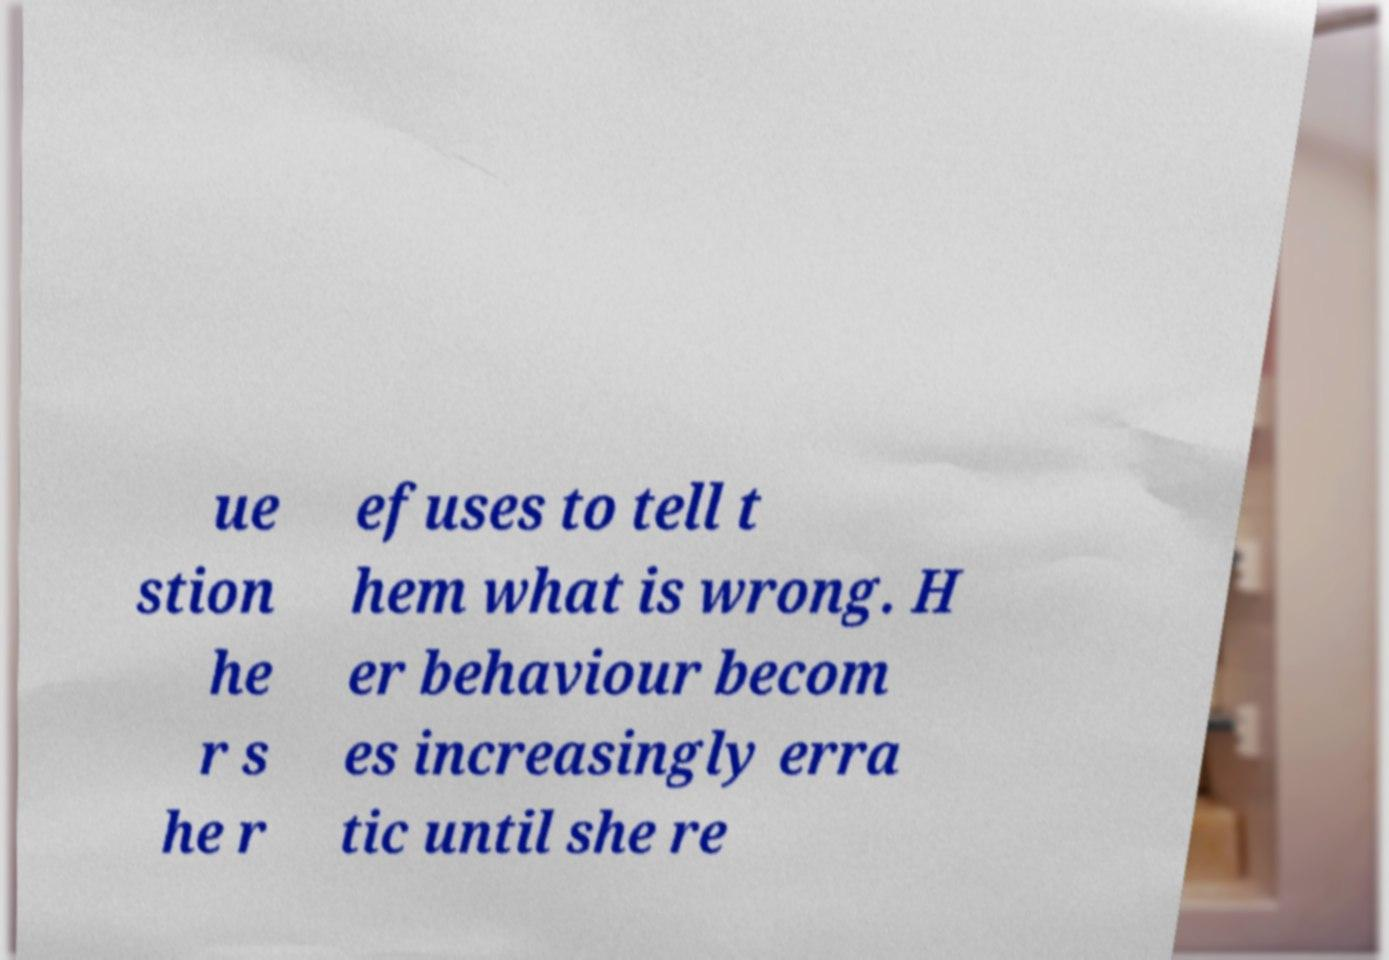For documentation purposes, I need the text within this image transcribed. Could you provide that? ue stion he r s he r efuses to tell t hem what is wrong. H er behaviour becom es increasingly erra tic until she re 